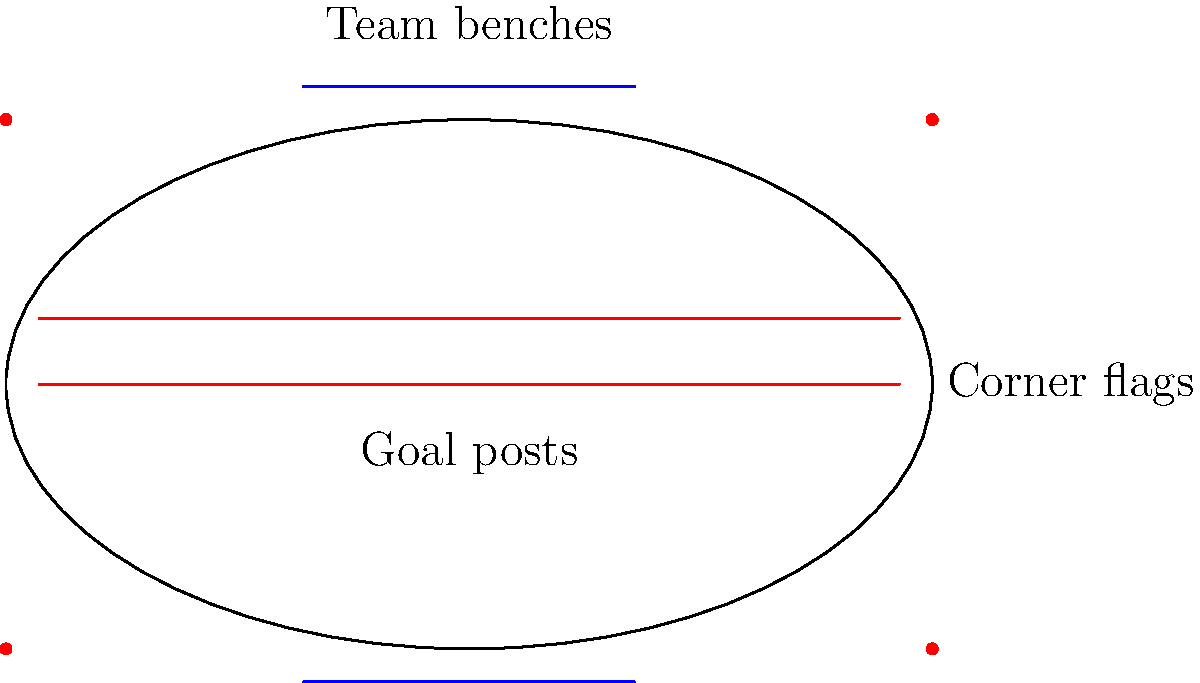In the panoramic stadium image above, how many total elements are there when combining the number of goal posts, corner flags, and team benches? To answer this question, we need to count each of the specified elements in the image:

1. Goal posts: There are 2 horizontal red lines representing goal posts.
2. Corner flags: There are 4 red dots in the corners of the stadium, representing corner flags.
3. Team benches: There are 2 blue lines outside the stadium outline, representing team benches.

Now, we sum up these counts:
$$ \text{Total elements} = \text{Goal posts} + \text{Corner flags} + \text{Team benches} $$
$$ \text{Total elements} = 2 + 4 + 2 = 8 $$

Therefore, the total number of elements when combining goal posts, corner flags, and team benches is 8.
Answer: 8 